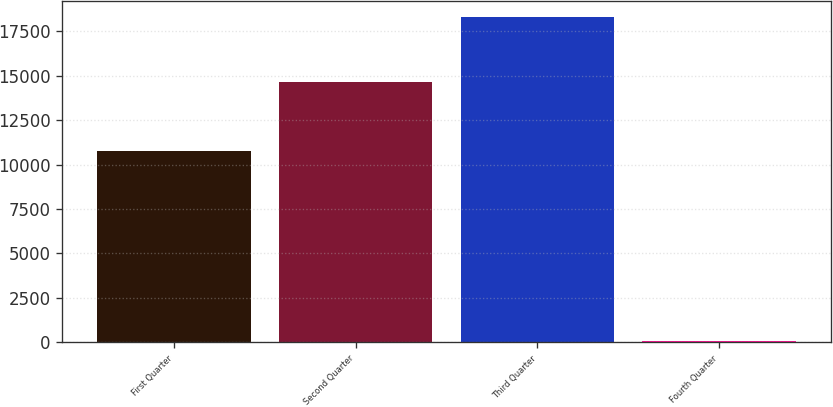Convert chart. <chart><loc_0><loc_0><loc_500><loc_500><bar_chart><fcel>First Quarter<fcel>Second Quarter<fcel>Third Quarter<fcel>Fourth Quarter<nl><fcel>10737<fcel>14641<fcel>18288<fcel>46<nl></chart> 